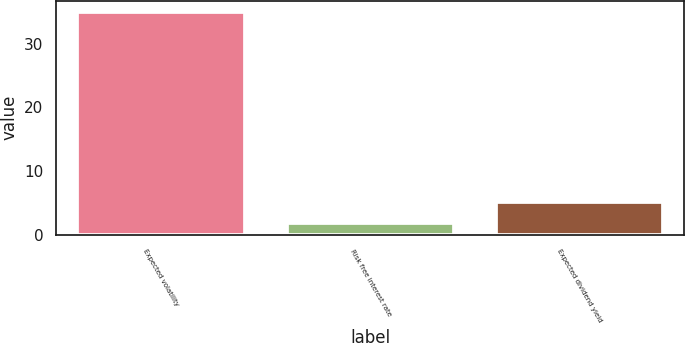<chart> <loc_0><loc_0><loc_500><loc_500><bar_chart><fcel>Expected volatility<fcel>Risk free interest rate<fcel>Expected dividend yield<nl><fcel>35<fcel>1.95<fcel>5.25<nl></chart> 